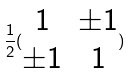Convert formula to latex. <formula><loc_0><loc_0><loc_500><loc_500>\frac { 1 } { 2 } ( \begin{matrix} 1 & \pm 1 \\ \pm 1 & 1 \end{matrix} )</formula> 